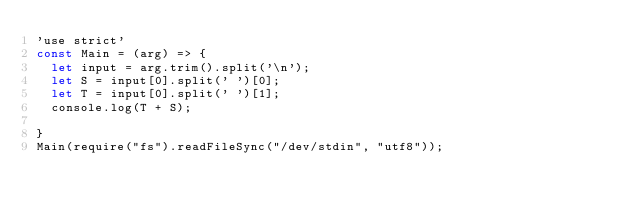<code> <loc_0><loc_0><loc_500><loc_500><_JavaScript_>'use strict'
const Main = (arg) => {
  let input = arg.trim().split('\n');
  let S = input[0].split(' ')[0];
  let T = input[0].split(' ')[1];
  console.log(T + S);

}
Main(require("fs").readFileSync("/dev/stdin", "utf8"));
</code> 